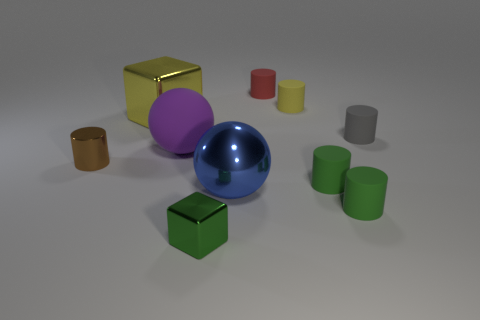Subtract all small rubber cylinders. How many cylinders are left? 1 Subtract all spheres. How many objects are left? 8 Subtract 1 blocks. How many blocks are left? 1 Subtract 1 blue spheres. How many objects are left? 9 Subtract all yellow cylinders. Subtract all gray spheres. How many cylinders are left? 5 Subtract all brown balls. How many green cubes are left? 1 Subtract all big brown blocks. Subtract all big purple rubber things. How many objects are left? 9 Add 3 red rubber things. How many red rubber things are left? 4 Add 7 yellow shiny blocks. How many yellow shiny blocks exist? 8 Subtract all brown cylinders. How many cylinders are left? 5 